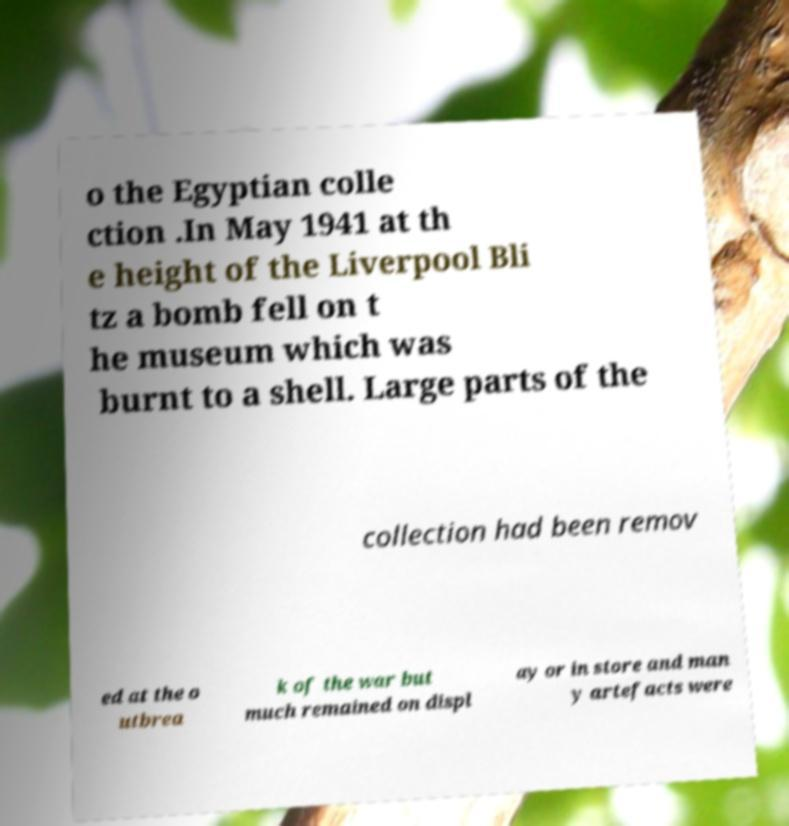There's text embedded in this image that I need extracted. Can you transcribe it verbatim? o the Egyptian colle ction .In May 1941 at th e height of the Liverpool Bli tz a bomb fell on t he museum which was burnt to a shell. Large parts of the collection had been remov ed at the o utbrea k of the war but much remained on displ ay or in store and man y artefacts were 